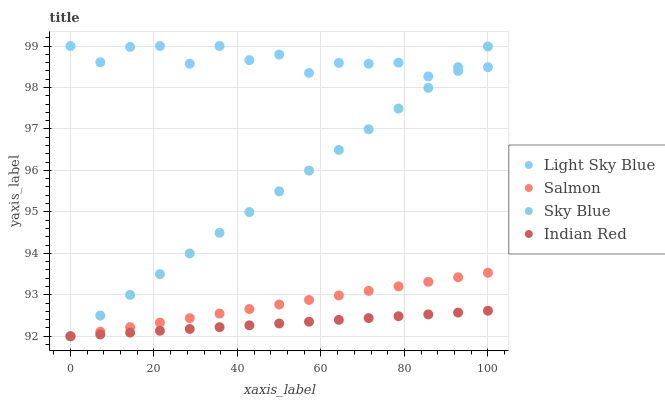Does Indian Red have the minimum area under the curve?
Answer yes or no. Yes. Does Light Sky Blue have the maximum area under the curve?
Answer yes or no. Yes. Does Salmon have the minimum area under the curve?
Answer yes or no. No. Does Salmon have the maximum area under the curve?
Answer yes or no. No. Is Sky Blue the smoothest?
Answer yes or no. Yes. Is Light Sky Blue the roughest?
Answer yes or no. Yes. Is Salmon the smoothest?
Answer yes or no. No. Is Salmon the roughest?
Answer yes or no. No. Does Sky Blue have the lowest value?
Answer yes or no. Yes. Does Light Sky Blue have the lowest value?
Answer yes or no. No. Does Light Sky Blue have the highest value?
Answer yes or no. Yes. Does Salmon have the highest value?
Answer yes or no. No. Is Indian Red less than Light Sky Blue?
Answer yes or no. Yes. Is Light Sky Blue greater than Indian Red?
Answer yes or no. Yes. Does Salmon intersect Sky Blue?
Answer yes or no. Yes. Is Salmon less than Sky Blue?
Answer yes or no. No. Is Salmon greater than Sky Blue?
Answer yes or no. No. Does Indian Red intersect Light Sky Blue?
Answer yes or no. No. 